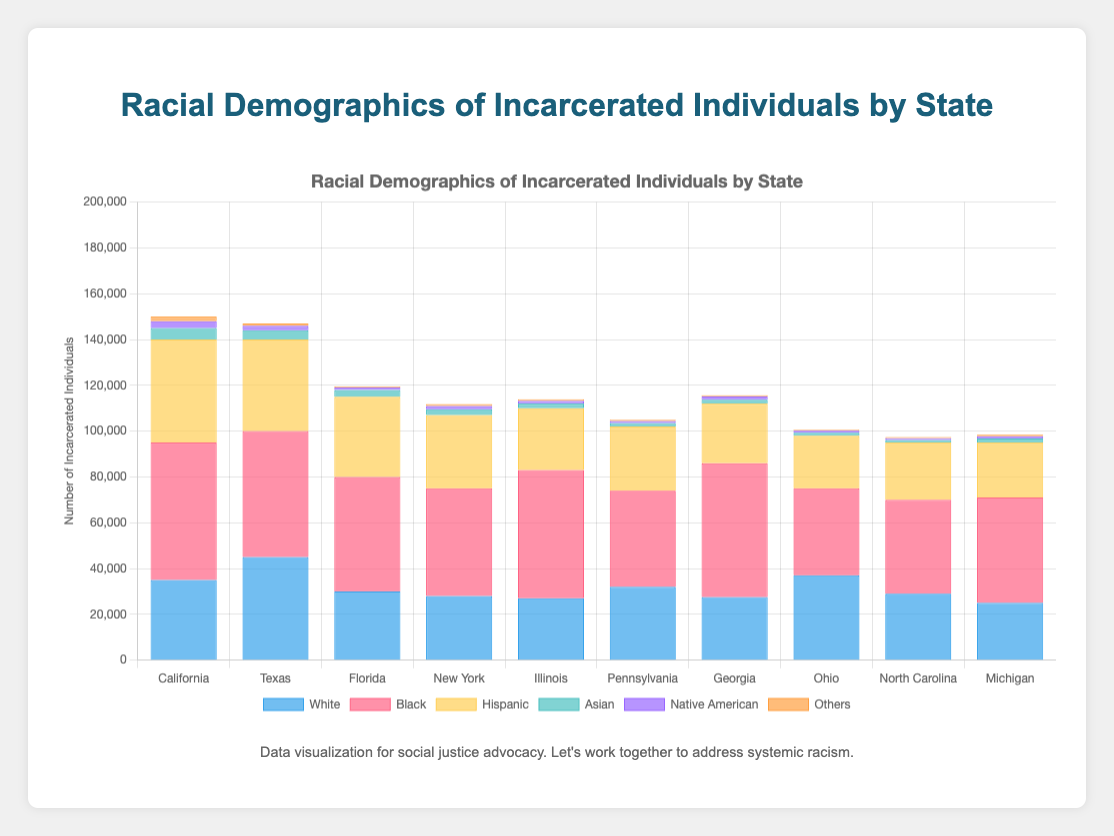Which state has the highest number of incarcerated Black individuals? To find this, compare the data for Black individuals in each state. The highest value is 58500 in Georgia.
Answer: Georgia Which racial group has the least number of incarcerated individuals in Florida? Check the data for Florida across all racial groups. The "Others" group has the least with 500.
Answer: Others How many more incarcerated individuals are there in California compared to Michigan? Sum up all individuals in each state, then find the difference. California: 35000+60000+45000+5000+3000+2000=150000, Michigan: 25000+46000+24000+1800+950+700=98500. Difference: 150000 - 98500 = 51500.
Answer: 51500 Which state has the largest disparity between incarcerated White and Black individuals? Calculate the absolute difference between White and Black individuals for each state. The largest disparity is in Georgia:
Answer: 31000 Which two racial groups have nearly equal numbers of incarcerated individuals in Ohio? Compare the numbers for each racial group in Ohio. The closest numbers are for White (37000) and Black (38000).
Answer: White and Black What is the total number of incarcerated Asian individuals across all states shown? Sum the Asian populations from all states: 5000+4000+3000+2500+2000+1500+1700+1300+1100+1800=26900.
Answer: 26900 What is the average number of incarcerated Native American individuals across all the states listed? Sum up the Native American individuals and divide by the number of states. Total: 3000+2000+1000+1500+1200+900+1400+900+800+950=13650. Average: 13650/10=1365.
Answer: 1365 Which state has the second highest number of incarcerated Hispanic individuals? Arrange the states by the number of Hispanic individuals. The second highest value is 40000 in Texas.
Answer: Texas Which state has the highest overall number of incarcerated individuals? Sum up the total for each state and compare. California has the highest total: 150000.
Answer: California In Pennsylvania, how many more incarcerated Black individuals are there compared to Hispanic individuals? Difference between Black and Hispanic individuals in Pennsylvania: 42000 - 28000 = 14000.
Answer: 14000 